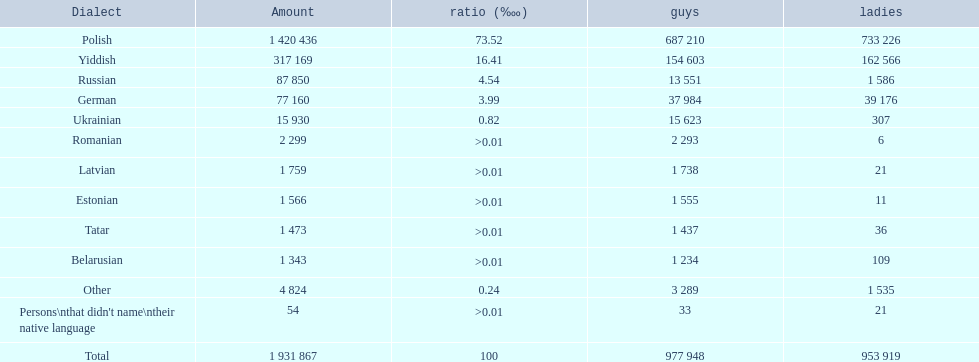Which languages are spoken by more than 50,000 people? Polish, Yiddish, Russian, German. Of these languages, which ones are spoken by less than 15% of the population? Russian, German. Of the remaining two, which one is spoken by 37,984 males? German. 